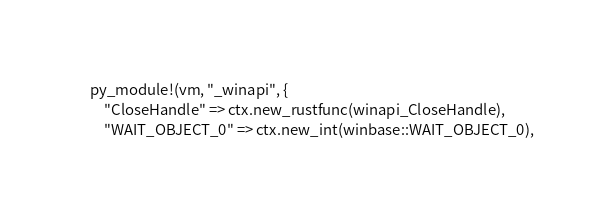Convert code to text. <code><loc_0><loc_0><loc_500><loc_500><_Rust_>    py_module!(vm, "_winapi", {
        "CloseHandle" => ctx.new_rustfunc(winapi_CloseHandle),
        "WAIT_OBJECT_0" => ctx.new_int(winbase::WAIT_OBJECT_0),</code> 